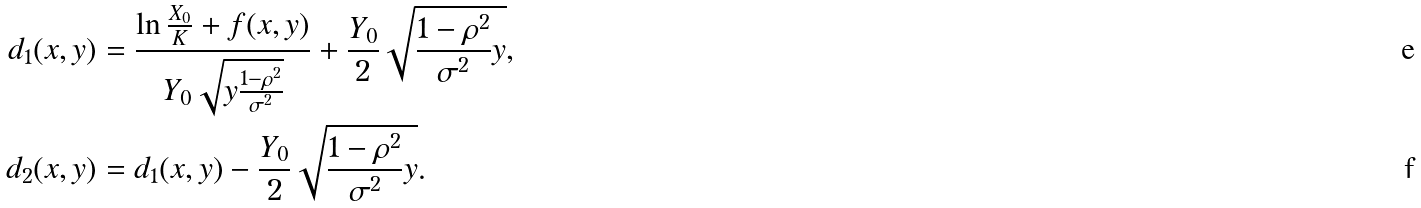<formula> <loc_0><loc_0><loc_500><loc_500>d _ { 1 } ( x , y ) & = \frac { \ln { \frac { X _ { 0 } } { K } } + f ( x , y ) } { Y _ { 0 } \sqrt { y \frac { 1 - \rho ^ { 2 } } { \sigma ^ { 2 } } } } + \frac { Y _ { 0 } } { 2 } \sqrt { \frac { 1 - \rho ^ { 2 } } { \sigma ^ { 2 } } y } , \\ d _ { 2 } ( x , y ) & = d _ { 1 } ( x , y ) - \frac { Y _ { 0 } } { 2 } \sqrt { \frac { 1 - \rho ^ { 2 } } { \sigma ^ { 2 } } y } .</formula> 